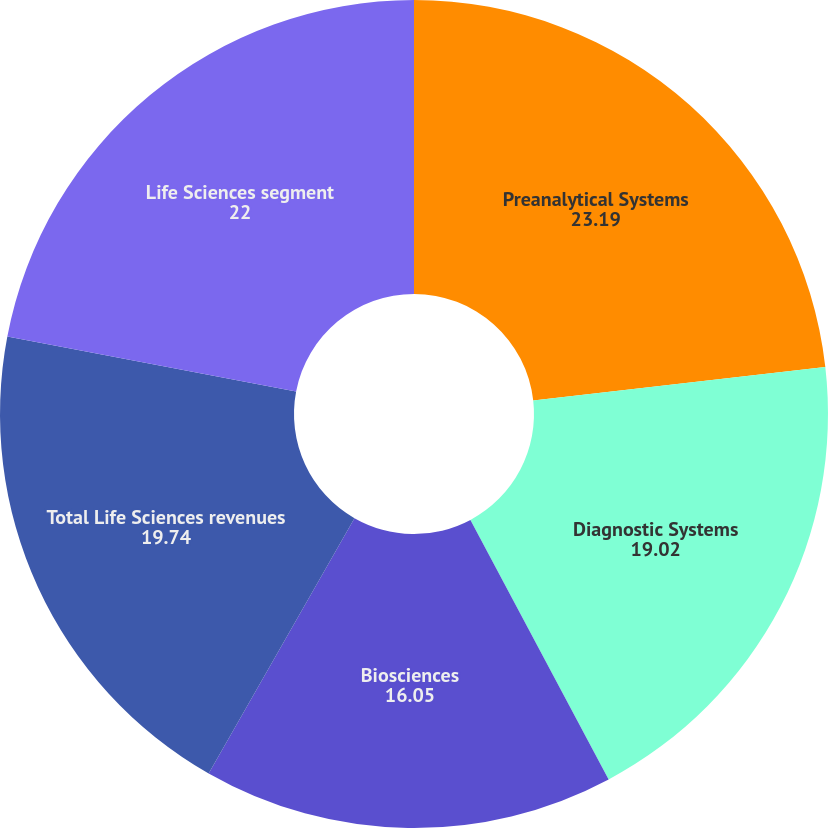Convert chart. <chart><loc_0><loc_0><loc_500><loc_500><pie_chart><fcel>Preanalytical Systems<fcel>Diagnostic Systems<fcel>Biosciences<fcel>Total Life Sciences revenues<fcel>Life Sciences segment<nl><fcel>23.19%<fcel>19.02%<fcel>16.05%<fcel>19.74%<fcel>22.0%<nl></chart> 